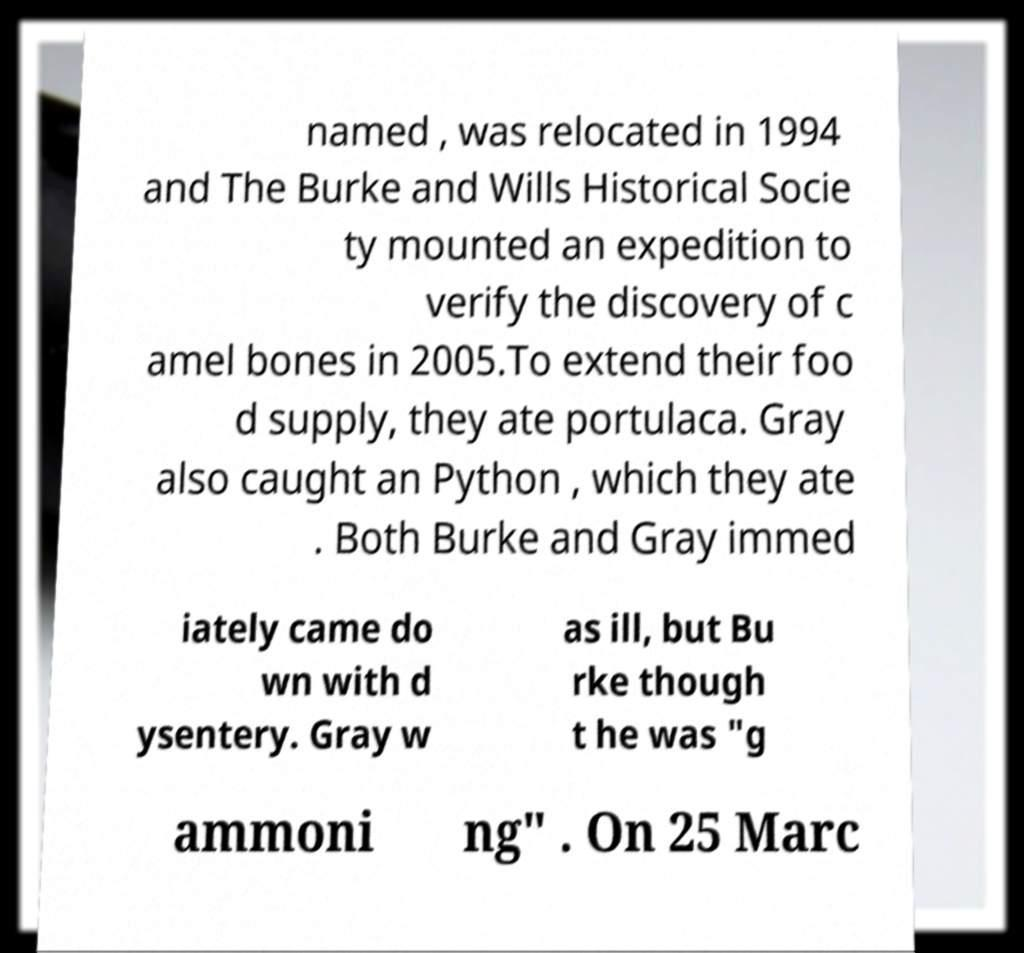Please read and relay the text visible in this image. What does it say? named , was relocated in 1994 and The Burke and Wills Historical Socie ty mounted an expedition to verify the discovery of c amel bones in 2005.To extend their foo d supply, they ate portulaca. Gray also caught an Python , which they ate . Both Burke and Gray immed iately came do wn with d ysentery. Gray w as ill, but Bu rke though t he was "g ammoni ng" . On 25 Marc 